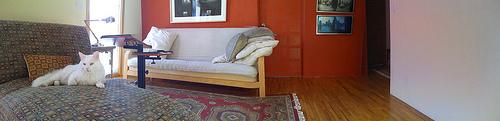Describe the color of the wall and any unique features found on it. The wall has a large section painted orange, with a white light switch and two pictures hanging on it. Provide a description of a decorative piece in the room. There are two sets of rectangular shaped pictures in frames hanging on the orange wall. Discuss an object in the scene which may reveal the room's overall sentiment. The multi-colored area rug with white fringe on the end brings a cozy and warm feeling to the space. Count the total number of pillows in the room and specify their arrangement. There are many pillows, mainly stacked on the corner of the couch and distributed on the futon. What do you notice about the entrance or doorway in the image? An entryway to a hallway is found to the right of the futon. Elaborate on the lighting arrangement in the space. An adjustable metal lamp is placed on a small table by a large window. What type of rug can be seen in the room, and where is it placed? A red Persian rug is on the hardwood floor in the living room. What material is the floor made of? The floor in the image is made of shiny brown hardwood. Mention a piece of furniture and describe its appearance. The white futon has a light-colored wood frame and several pillows. Can you tell me about the pet in the image and its location? A beautiful white adult cat is resting on a small bed, near a pillow on the sofa. 